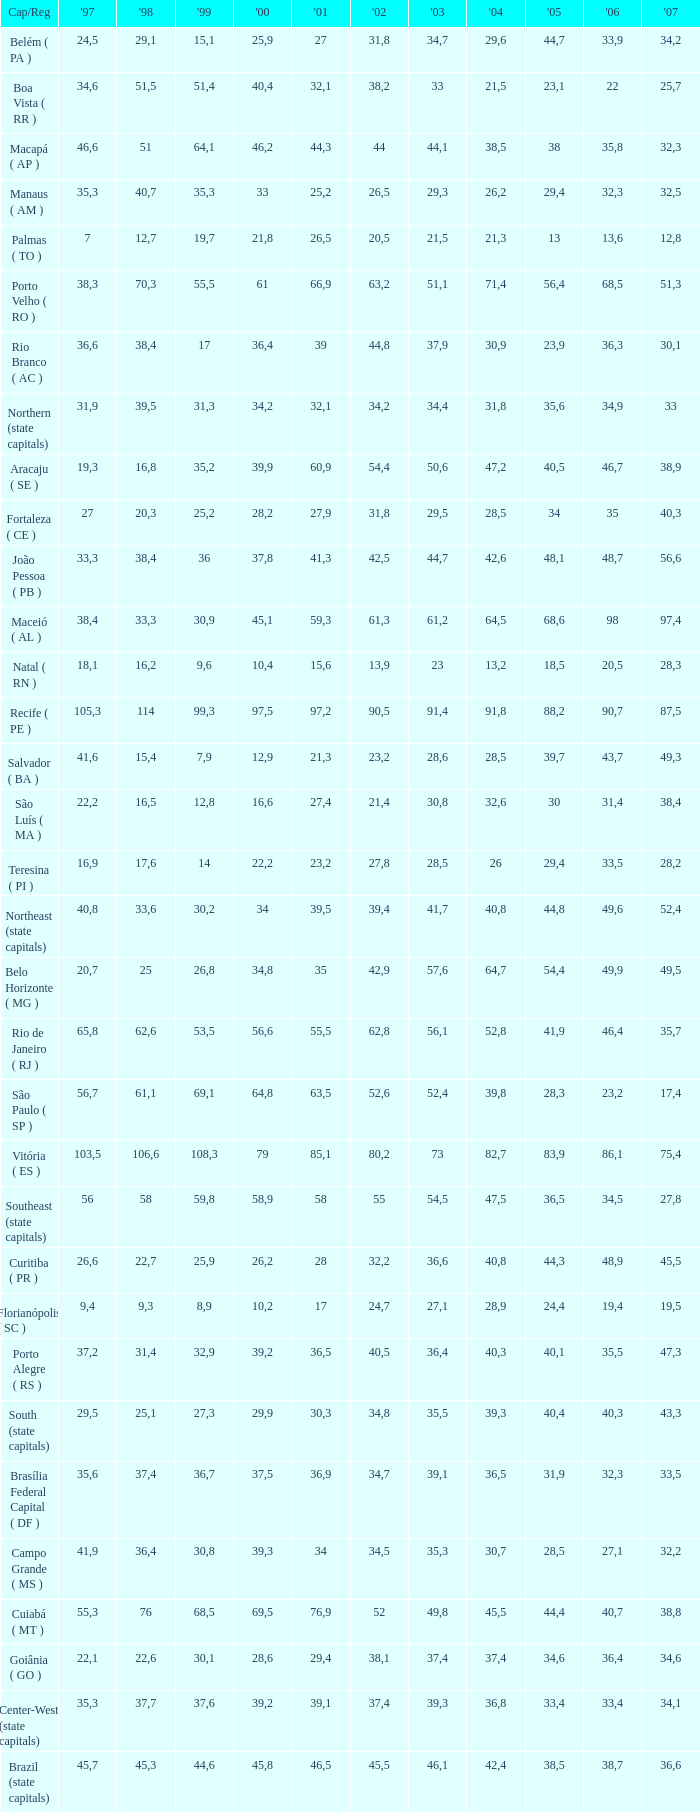What is the average 2000 that has a 1997 greater than 34,6, a 2006 greater than 38,7, and a 2998 less than 76? 41.92. 